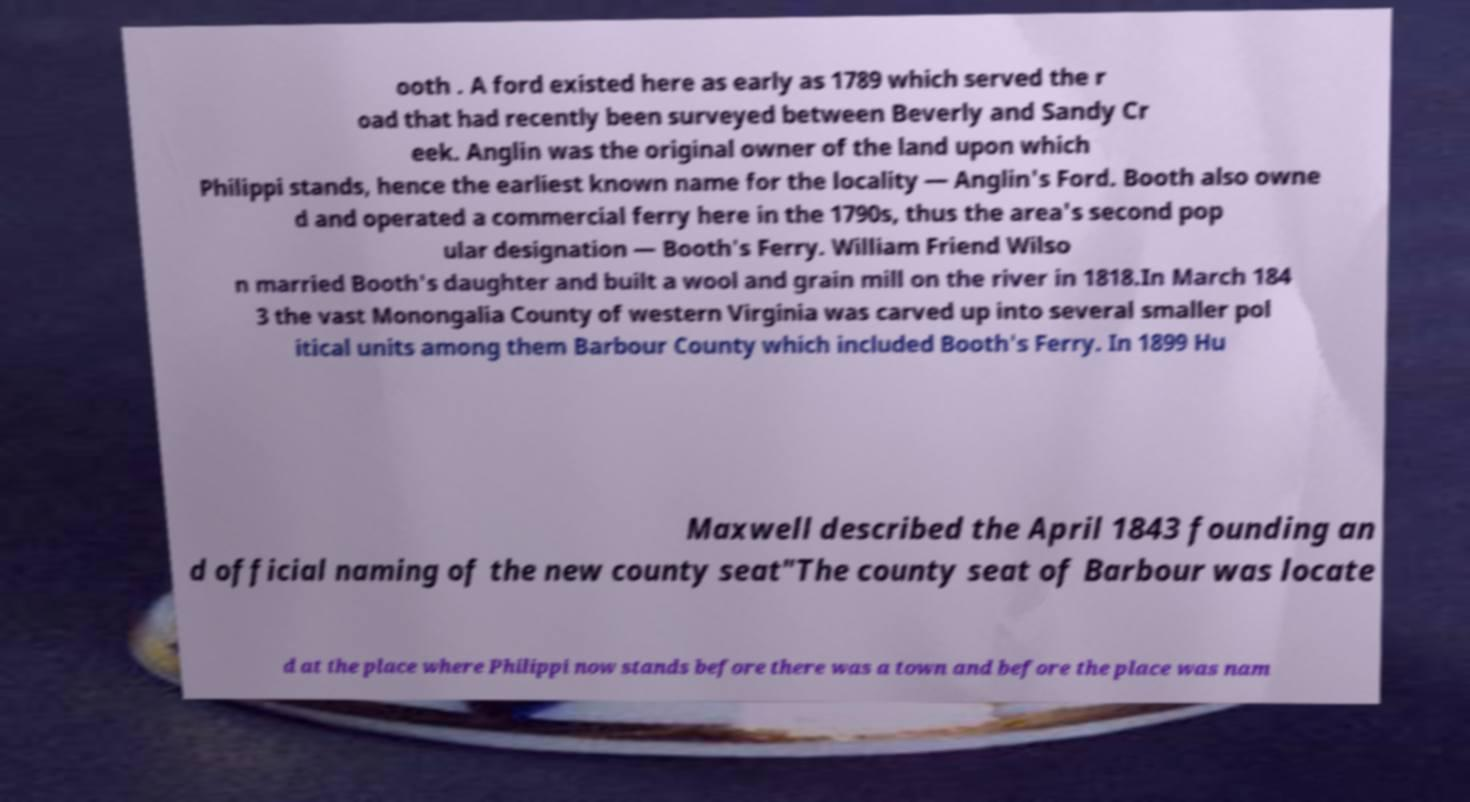There's text embedded in this image that I need extracted. Can you transcribe it verbatim? ooth . A ford existed here as early as 1789 which served the r oad that had recently been surveyed between Beverly and Sandy Cr eek. Anglin was the original owner of the land upon which Philippi stands, hence the earliest known name for the locality — Anglin's Ford. Booth also owne d and operated a commercial ferry here in the 1790s, thus the area's second pop ular designation — Booth's Ferry. William Friend Wilso n married Booth's daughter and built a wool and grain mill on the river in 1818.In March 184 3 the vast Monongalia County of western Virginia was carved up into several smaller pol itical units among them Barbour County which included Booth's Ferry. In 1899 Hu Maxwell described the April 1843 founding an d official naming of the new county seat"The county seat of Barbour was locate d at the place where Philippi now stands before there was a town and before the place was nam 